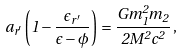Convert formula to latex. <formula><loc_0><loc_0><loc_500><loc_500>a _ { r ^ { \prime } } \left ( 1 - \frac { \epsilon _ { r ^ { \prime } } } { \epsilon - \phi } \right ) = \frac { G m _ { 1 } ^ { 2 } m _ { 2 } } { 2 M ^ { 2 } c ^ { 2 } } \, ,</formula> 